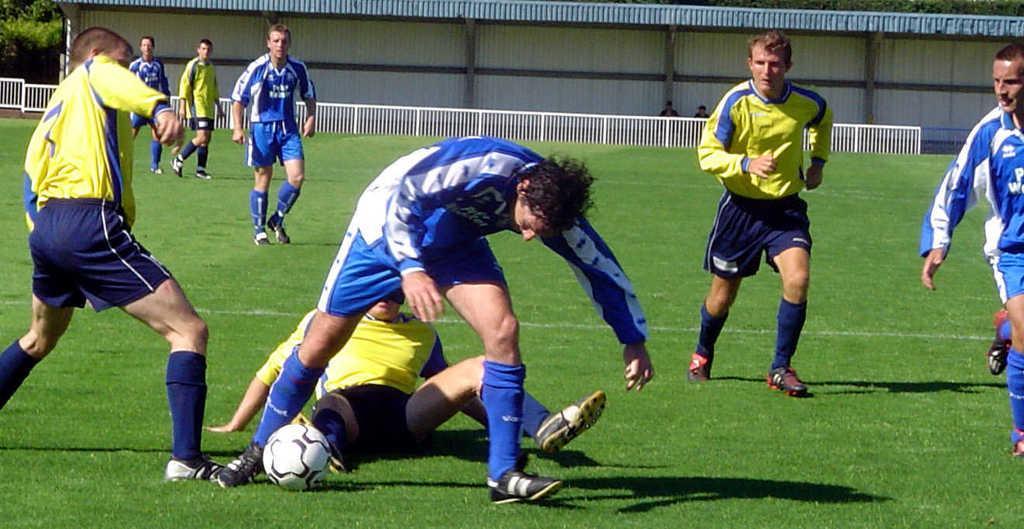Could you give a brief overview of what you see in this image? In this Image I see number of men who are on the grass and this man is sitting and I can also see a football over here. In the background I see 2 more persons and the fence. 